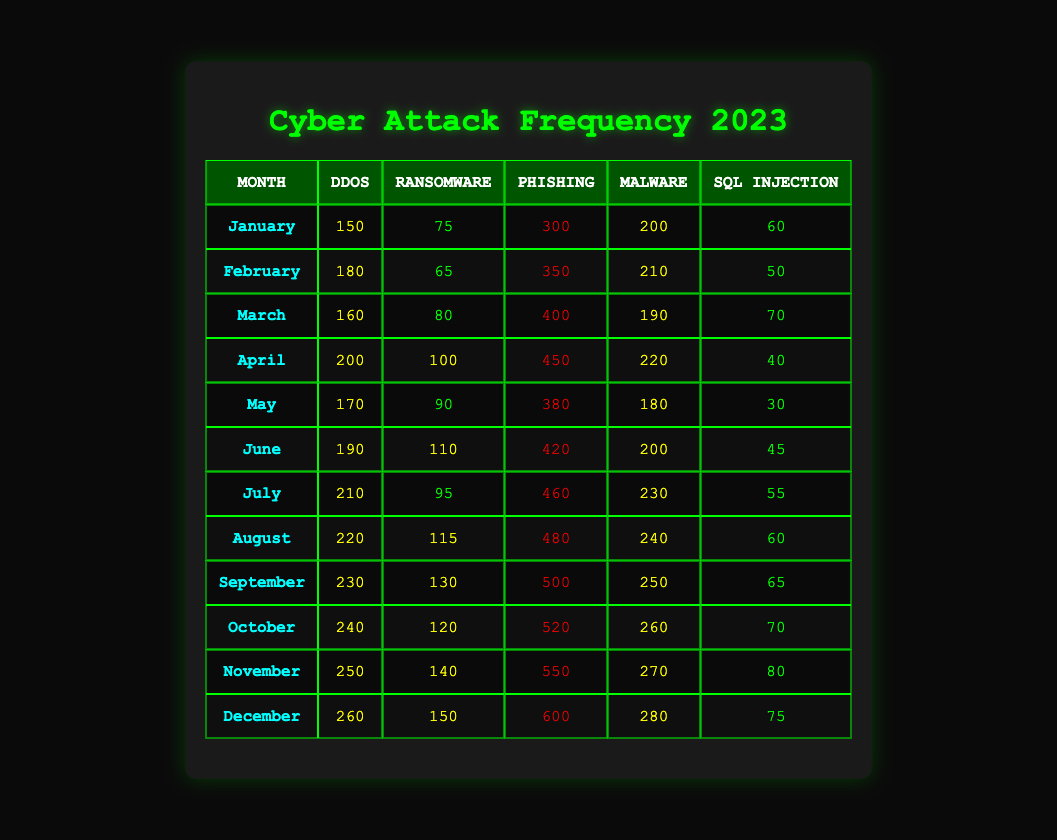What is the total number of DDoS attacks in June? The table lists DDoS attacks in June as 190. Thus, the total number of DDoS attacks for that month is simply the value in the June row for DDoS.
Answer: 190 Which month had the highest number of Phishing attacks? Looking through the table, December shows the highest figure for Phishing attacks at 600. Therefore, December had the highest number of Phishing attacks.
Answer: December What is the average number of Ransomware attacks from January to March? The number of Ransomware attacks for the three months are: January (75), February (65), and March (80). To find the average, sum these values: 75 + 65 + 80 = 220. Then divide by 3 (the number of months): 220 / 3 = approximately 73.33.
Answer: 73.33 Did the number of Malware attacks decrease from April to May? In April, there were 220 Malware attacks and in May, there were 180. Since 180 is less than 220, this indicates a decrease in attacks.
Answer: Yes What was the difference in the number of SQL Injection attacks between November and December? In November, there were 80 SQL Injection attacks and in December, there were 75. To find the difference: 80 - 75 = 5. Thus, the difference is 5 attacks.
Answer: 5 Which type of cyber attack had the highest frequency in October? In October, the Phishing attacks reached 520, which is higher than any other type listed for that month: DDoS (240), Ransomware (120), Malware (260), and SQL Injection (70). Thus, Phishing had the highest frequency in October.
Answer: Phishing What is the trend of DDoS attacks from January to December? Looking at the values: January (150), February (180), March (160), April (200), May (170), June (190), July (210), August (220), September (230), October (240), November (250), December (260). The values show an overall increasing trend throughout the year.
Answer: Increasing How many total cyber attacks were recorded in August? To find the total in August, sum the attacks: DDoS (220), Ransomware (115), Phishing (480), Malware (240), SQL Injection (60). Adding these numbers gives: 220 + 115 + 480 + 240 + 60 = 1115. Therefore, the total number of cyber attacks in August is 1115.
Answer: 1115 Was the total number of Phishing attacks in the first half of the year greater than that in the second half? The first half (January to June): 300 + 350 + 400 + 450 + 380 + 420 = 2300. For the second half (July to December): 460 + 480 + 500 + 520 + 550 + 600 = 3180. The second half (3180) is greater than the first half (2300).
Answer: No 